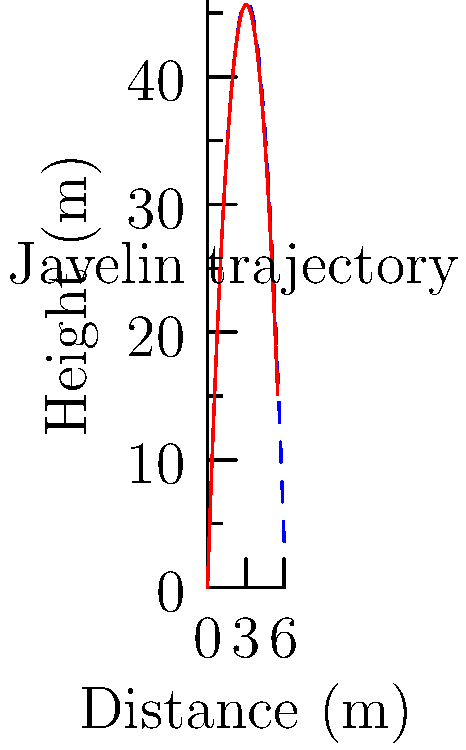In a javelin throw simulation, we model the trajectory with and without air resistance. The blue dashed line represents the ideal parabolic path without air resistance, while the red solid line shows the realistic path with air resistance. Given that both trajectories start with the same initial velocity and angle, what key difference in the paths demonstrates the impact of air resistance on the javelin's flight? To analyze the impact of air resistance on the javelin's flight, we'll follow these steps:

1. Ideal trajectory (without air resistance):
   - Represented by the blue dashed line
   - Follows a perfect parabolic path
   - Described by the equation: $$h(x) = h_0 + x\tan\theta - \frac{gx^2}{2v_0^2\cos^2\theta}$$
   Where $h$ is height, $x$ is horizontal distance, $h_0$ is initial height, $\theta$ is launch angle, $g$ is gravitational acceleration, and $v_0$ is initial velocity.

2. Realistic trajectory (with air resistance):
   - Represented by the red solid line
   - Deviates from the perfect parabolic path
   - Can be approximated by adding a drag term: $$h(x) = h_0 + x\tan\theta - \frac{gx^2}{2v_0^2\cos^2\theta} - kx^3$$
   Where $k$ is a drag coefficient dependent on the javelin's properties and air density.

3. Key differences:
   a. Maximum height: The realistic path reaches a lower maximum height.
   b. Range: The javelin with air resistance travels a shorter horizontal distance.
   c. Asymmetry: The realistic path is not symmetrical, with a steeper descent.
   d. Time of flight: The javelin under air resistance has a shorter time of flight.

4. Impact on performance:
   - Air resistance reduces the javelin's range and maximum height.
   - It affects the optimal release angle and velocity for maximum distance.
   - Understanding these effects is crucial for optimizing javelin throw techniques.

5. Computational considerations:
   - Simulating air resistance requires more complex calculations.
   - In resource-constrained systems, trade-offs between accuracy and computational efficiency must be considered.
   - Procedural programming can be efficiently used to implement iterative numerical methods for solving the equations of motion with air resistance.
Answer: The realistic path (red line) shows a lower maximum height and shorter range compared to the ideal path (blue dashed line), demonstrating the impact of air resistance. 